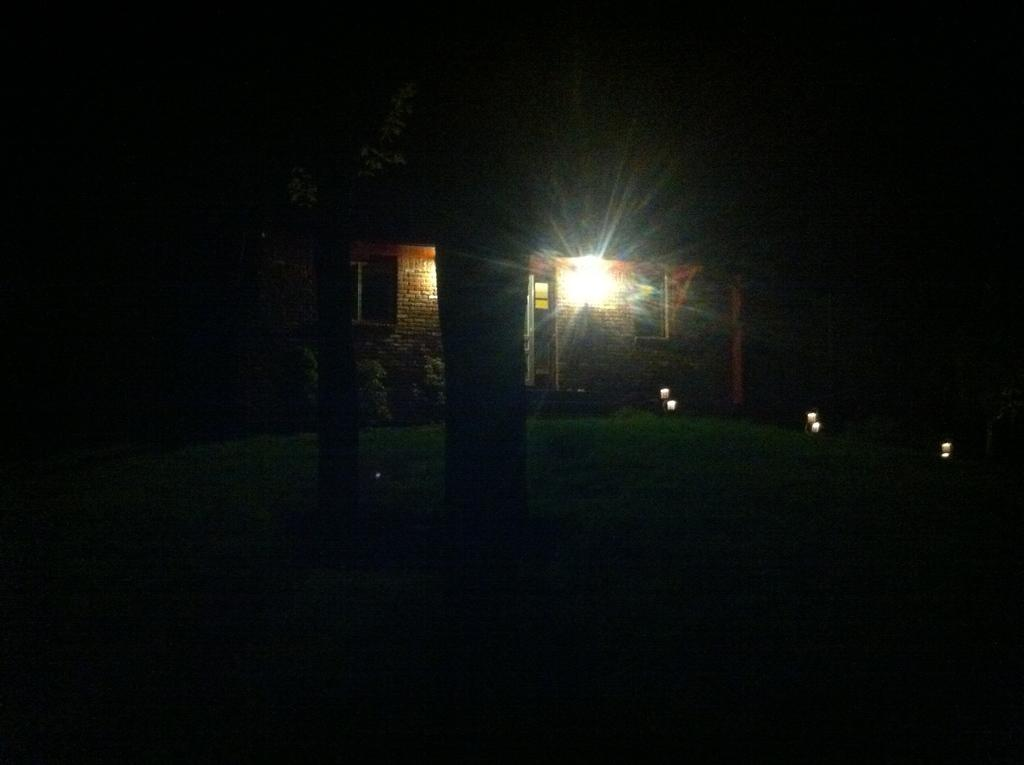What color is the building in the image? The building in the image is yellow-colored. What can be seen in the image besides the building? There is a light, plants, and grass visible in the image. What type of vegetation is present in the image? Plants and grass are present in the image. How would you describe the lighting in the image? The image appears to be in a dark setting. What type of watch can be seen on the mountain in the image? There is no watch or mountain present in the image. Is the camera visible in the image? There is no camera present in the image. 